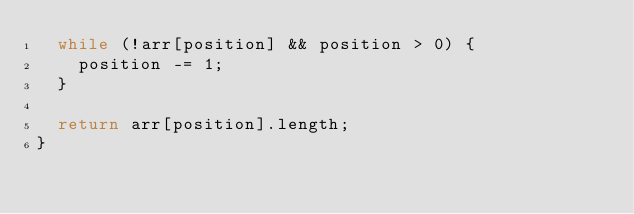<code> <loc_0><loc_0><loc_500><loc_500><_JavaScript_>  while (!arr[position] && position > 0) {
    position -= 1;
  }

  return arr[position].length;
}
</code> 